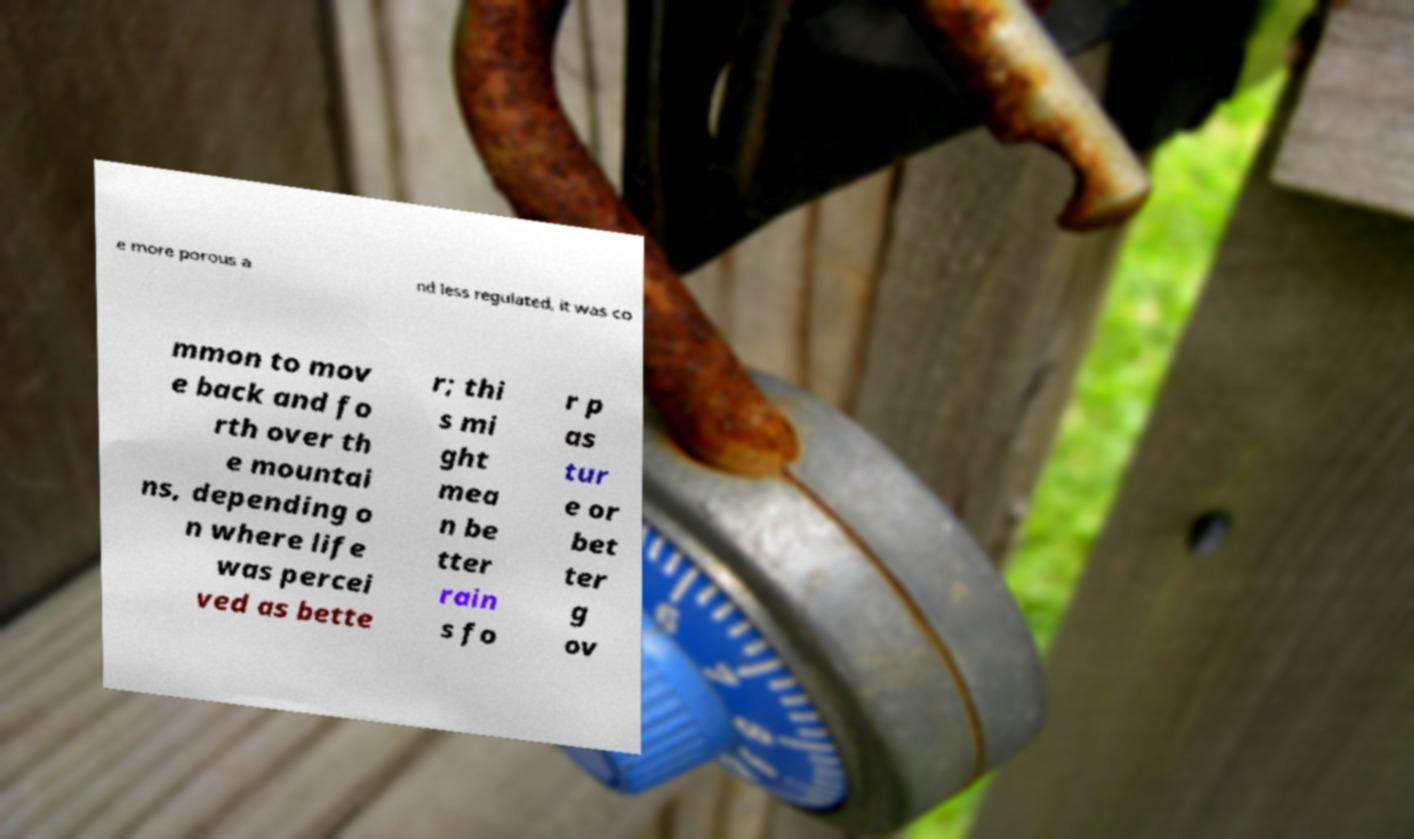Can you read and provide the text displayed in the image?This photo seems to have some interesting text. Can you extract and type it out for me? e more porous a nd less regulated, it was co mmon to mov e back and fo rth over th e mountai ns, depending o n where life was percei ved as bette r; thi s mi ght mea n be tter rain s fo r p as tur e or bet ter g ov 